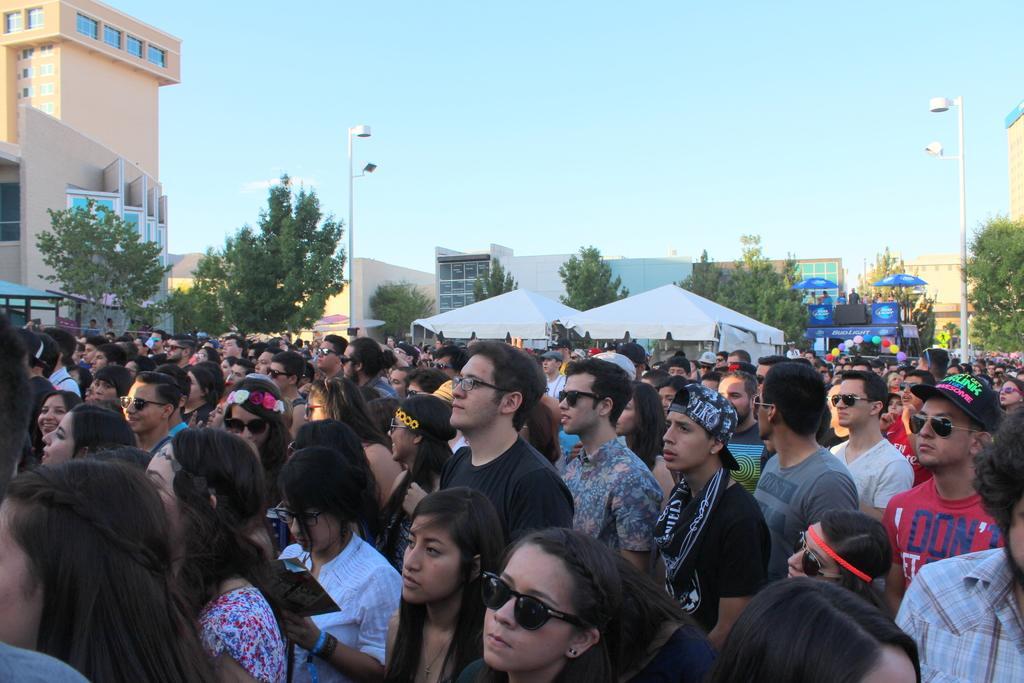How would you summarize this image in a sentence or two? In this image in the middle, there is a man, he wears a black t shirt, he is standing and there are many people. In the middle there are trees, tents, umbrellas, some people, street lights, poles, buildings and sky. 